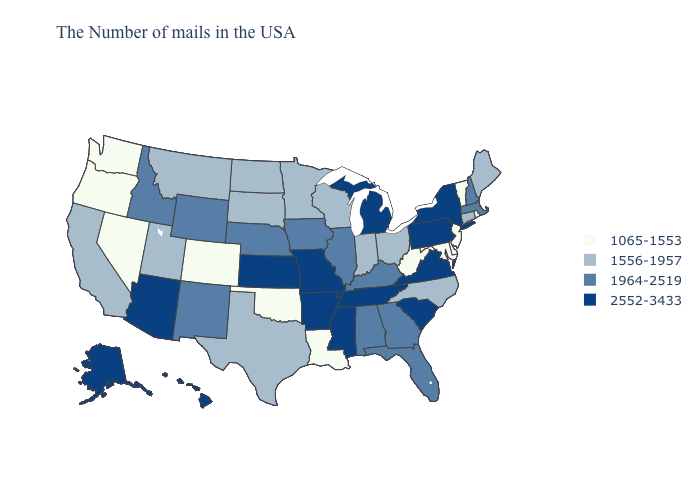What is the lowest value in states that border Utah?
Answer briefly. 1065-1553. What is the lowest value in the USA?
Write a very short answer. 1065-1553. What is the highest value in the USA?
Give a very brief answer. 2552-3433. What is the lowest value in the South?
Short answer required. 1065-1553. What is the highest value in the USA?
Write a very short answer. 2552-3433. Which states have the highest value in the USA?
Write a very short answer. New York, Pennsylvania, Virginia, South Carolina, Michigan, Tennessee, Mississippi, Missouri, Arkansas, Kansas, Arizona, Alaska, Hawaii. Name the states that have a value in the range 2552-3433?
Be succinct. New York, Pennsylvania, Virginia, South Carolina, Michigan, Tennessee, Mississippi, Missouri, Arkansas, Kansas, Arizona, Alaska, Hawaii. Does Connecticut have the highest value in the USA?
Quick response, please. No. Name the states that have a value in the range 2552-3433?
Short answer required. New York, Pennsylvania, Virginia, South Carolina, Michigan, Tennessee, Mississippi, Missouri, Arkansas, Kansas, Arizona, Alaska, Hawaii. Does the first symbol in the legend represent the smallest category?
Quick response, please. Yes. Does Indiana have the lowest value in the MidWest?
Keep it brief. Yes. Does Minnesota have the same value as Maryland?
Keep it brief. No. What is the value of Maryland?
Keep it brief. 1065-1553. What is the highest value in the USA?
Write a very short answer. 2552-3433. Which states have the lowest value in the USA?
Keep it brief. Rhode Island, Vermont, New Jersey, Delaware, Maryland, West Virginia, Louisiana, Oklahoma, Colorado, Nevada, Washington, Oregon. 